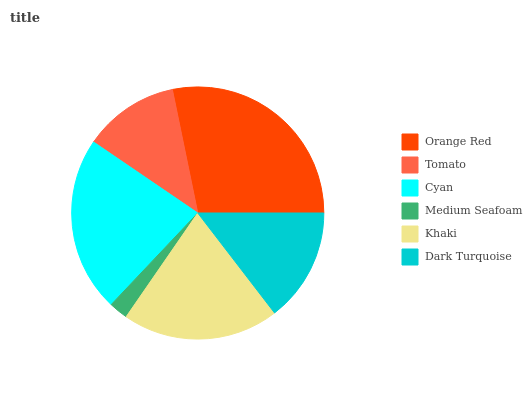Is Medium Seafoam the minimum?
Answer yes or no. Yes. Is Orange Red the maximum?
Answer yes or no. Yes. Is Tomato the minimum?
Answer yes or no. No. Is Tomato the maximum?
Answer yes or no. No. Is Orange Red greater than Tomato?
Answer yes or no. Yes. Is Tomato less than Orange Red?
Answer yes or no. Yes. Is Tomato greater than Orange Red?
Answer yes or no. No. Is Orange Red less than Tomato?
Answer yes or no. No. Is Khaki the high median?
Answer yes or no. Yes. Is Dark Turquoise the low median?
Answer yes or no. Yes. Is Tomato the high median?
Answer yes or no. No. Is Orange Red the low median?
Answer yes or no. No. 